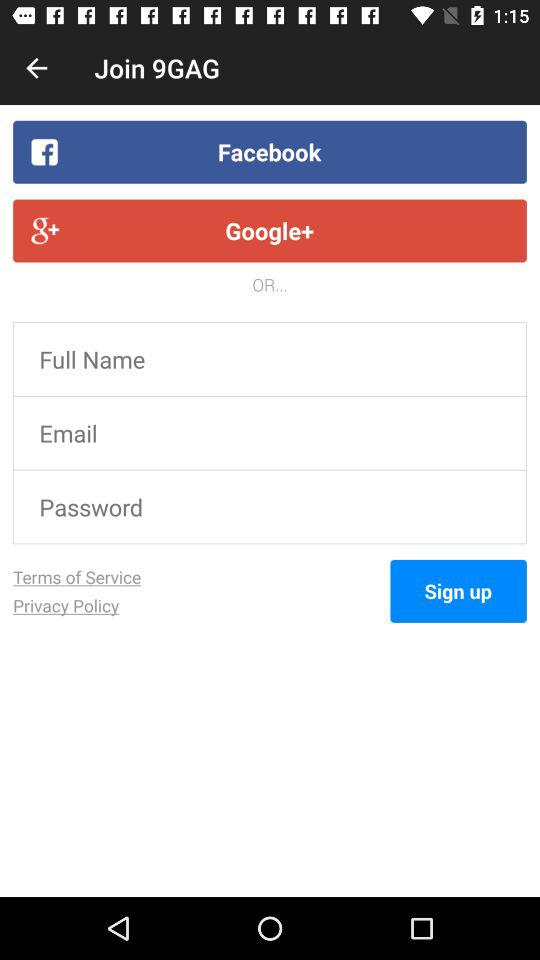What is the application name? The application name is "Join 9GAG". 